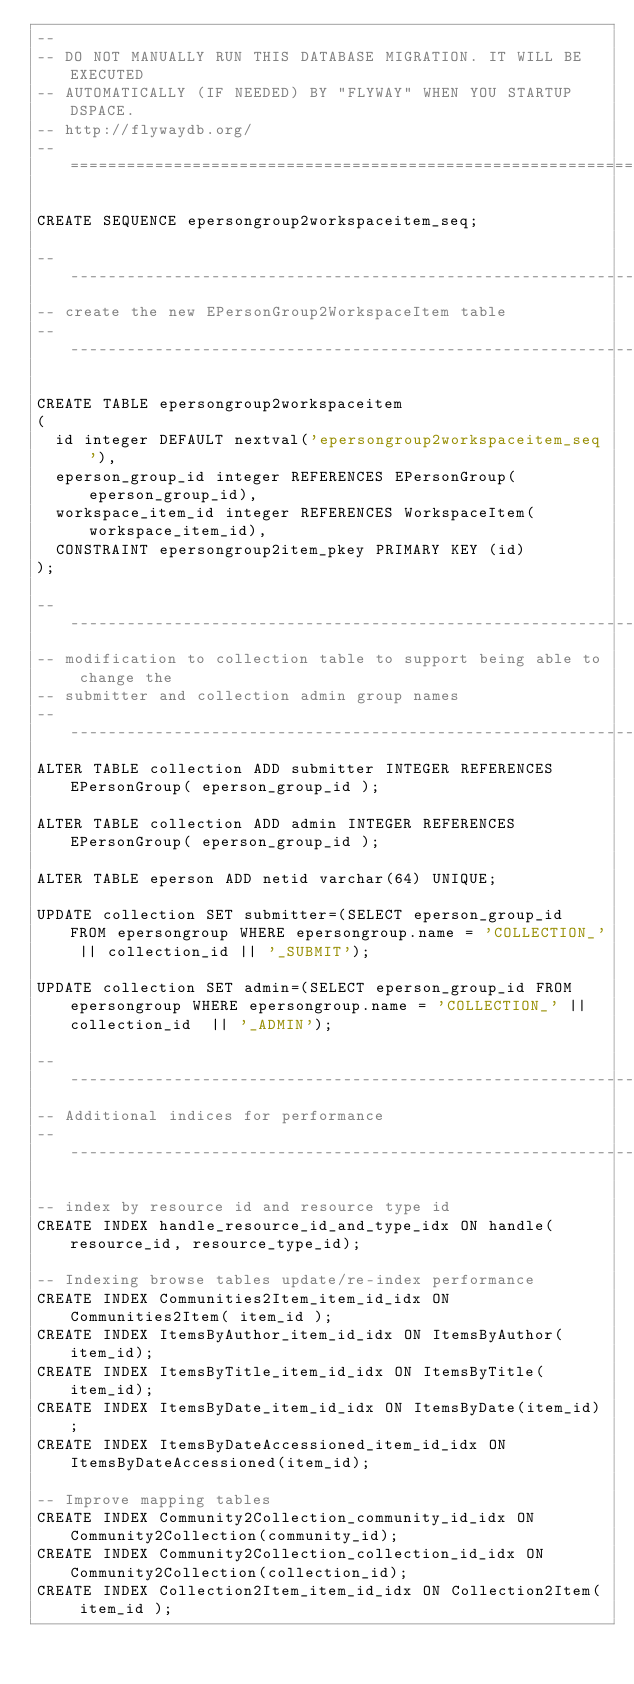<code> <loc_0><loc_0><loc_500><loc_500><_SQL_>--
-- DO NOT MANUALLY RUN THIS DATABASE MIGRATION. IT WILL BE EXECUTED
-- AUTOMATICALLY (IF NEEDED) BY "FLYWAY" WHEN YOU STARTUP DSPACE.
-- http://flywaydb.org/
-- ===============================================================

CREATE SEQUENCE epersongroup2workspaceitem_seq;

-------------------------------------------------------------------------------
-- create the new EPersonGroup2WorkspaceItem table
-------------------------------------------------------------------------------

CREATE TABLE epersongroup2workspaceitem 
(
  id integer DEFAULT nextval('epersongroup2workspaceitem_seq'),
  eperson_group_id integer REFERENCES EPersonGroup(eperson_group_id),
  workspace_item_id integer REFERENCES WorkspaceItem(workspace_item_id),
  CONSTRAINT epersongroup2item_pkey PRIMARY KEY (id)
);

-------------------------------------------------------------------------------
-- modification to collection table to support being able to change the
-- submitter and collection admin group names
-------------------------------------------------------------------------------
ALTER TABLE collection ADD submitter INTEGER REFERENCES EPersonGroup( eperson_group_id );

ALTER TABLE collection ADD admin INTEGER REFERENCES EPersonGroup( eperson_group_id );

ALTER TABLE eperson ADD netid varchar(64) UNIQUE;

UPDATE collection SET submitter=(SELECT eperson_group_id FROM epersongroup WHERE epersongroup.name = 'COLLECTION_' || collection_id || '_SUBMIT'); 

UPDATE collection SET admin=(SELECT eperson_group_id FROM epersongroup WHERE epersongroup.name = 'COLLECTION_' || collection_id  || '_ADMIN'); 

-------------------------------------------------------------------------------
-- Additional indices for performance
-------------------------------------------------------------------------------

-- index by resource id and resource type id
CREATE INDEX handle_resource_id_and_type_idx ON handle(resource_id, resource_type_id);

-- Indexing browse tables update/re-index performance
CREATE INDEX Communities2Item_item_id_idx ON Communities2Item( item_id );
CREATE INDEX ItemsByAuthor_item_id_idx ON ItemsByAuthor(item_id);
CREATE INDEX ItemsByTitle_item_id_idx ON ItemsByTitle(item_id);
CREATE INDEX ItemsByDate_item_id_idx ON ItemsByDate(item_id);
CREATE INDEX ItemsByDateAccessioned_item_id_idx ON ItemsByDateAccessioned(item_id);

-- Improve mapping tables
CREATE INDEX Community2Collection_community_id_idx ON Community2Collection(community_id);
CREATE INDEX Community2Collection_collection_id_idx ON Community2Collection(collection_id);
CREATE INDEX Collection2Item_item_id_idx ON Collection2Item( item_id );
</code> 